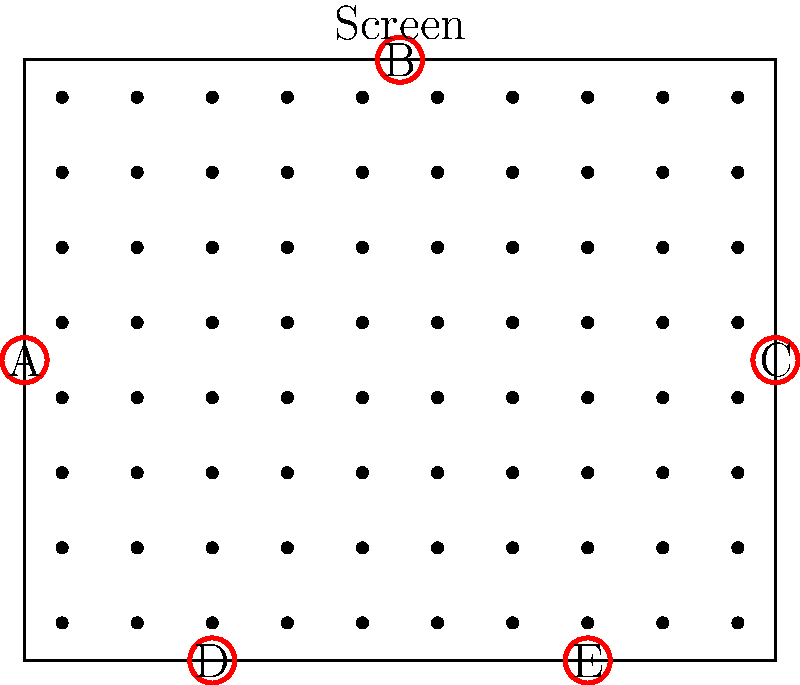In the theater layout shown, five speakers (A, B, C, D, and E) are positioned for a surround sound system. Which speaker should be designated as the center channel to optimize the audio experience for the majority of the audience? To determine the optimal center channel speaker for the surround sound system, we need to consider the following steps:

1. Understand the purpose of the center channel: It's primarily responsible for dialogue and centering the sound stage.

2. Analyze the theater layout:
   - The screen is located at the top of the diagram.
   - There are 8 rows and 10 columns of seats.
   - Speakers are positioned at the sides (A and C), top center (B), and bottom corners (D and E).

3. Consider the ideal placement for a center channel:
   - It should be as close to the screen as possible.
   - It should be centered horizontally relative to the seating area.

4. Evaluate each speaker position:
   - Speaker A: Left side, not centered.
   - Speaker B: Top center, closest to the screen.
   - Speaker C: Right side, not centered.
   - Speaker D: Bottom left, far from the screen.
   - Speaker E: Bottom right, far from the screen.

5. Choose the optimal speaker:
   Speaker B is the best choice for the center channel because:
   - It's positioned at the top center, directly below the screen.
   - It's centered horizontally relative to the seating arrangement.
   - It will provide the most consistent dialogue and centered sound for the majority of the audience.

Therefore, designating Speaker B as the center channel will optimize the audio experience for most viewers in this theater layout.
Answer: Speaker B 